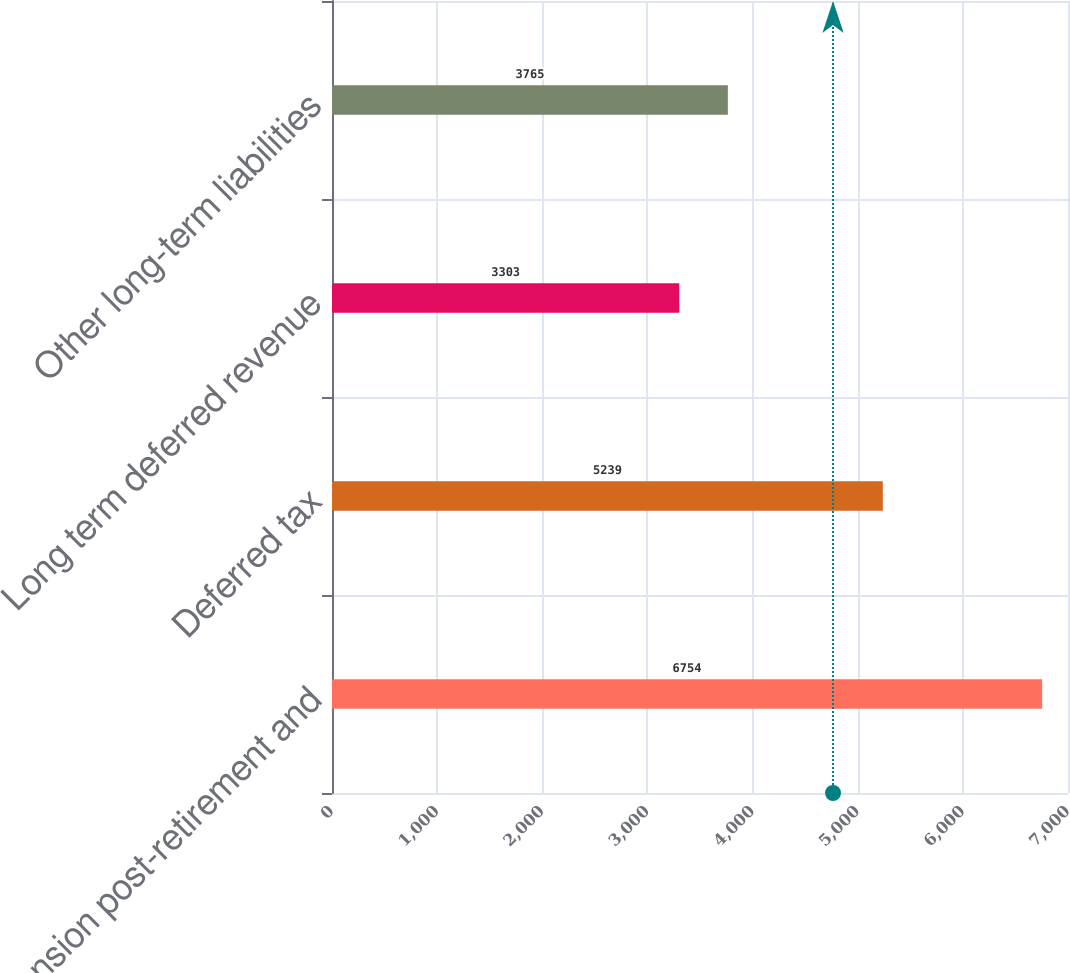Convert chart. <chart><loc_0><loc_0><loc_500><loc_500><bar_chart><fcel>Pension post-retirement and<fcel>Deferred tax<fcel>Long term deferred revenue<fcel>Other long-term liabilities<nl><fcel>6754<fcel>5239<fcel>3303<fcel>3765<nl></chart> 